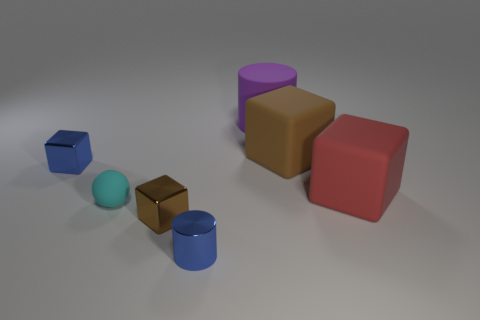Can you describe the lighting and its possible source in this scene? The lighting in the scene seems to be originating from above and to the right side, casting subtle shadows to the left of the objects. This type of lighting suggests a single diffused light source, such as a softbox or a cloudy sky in a simulated environment. 